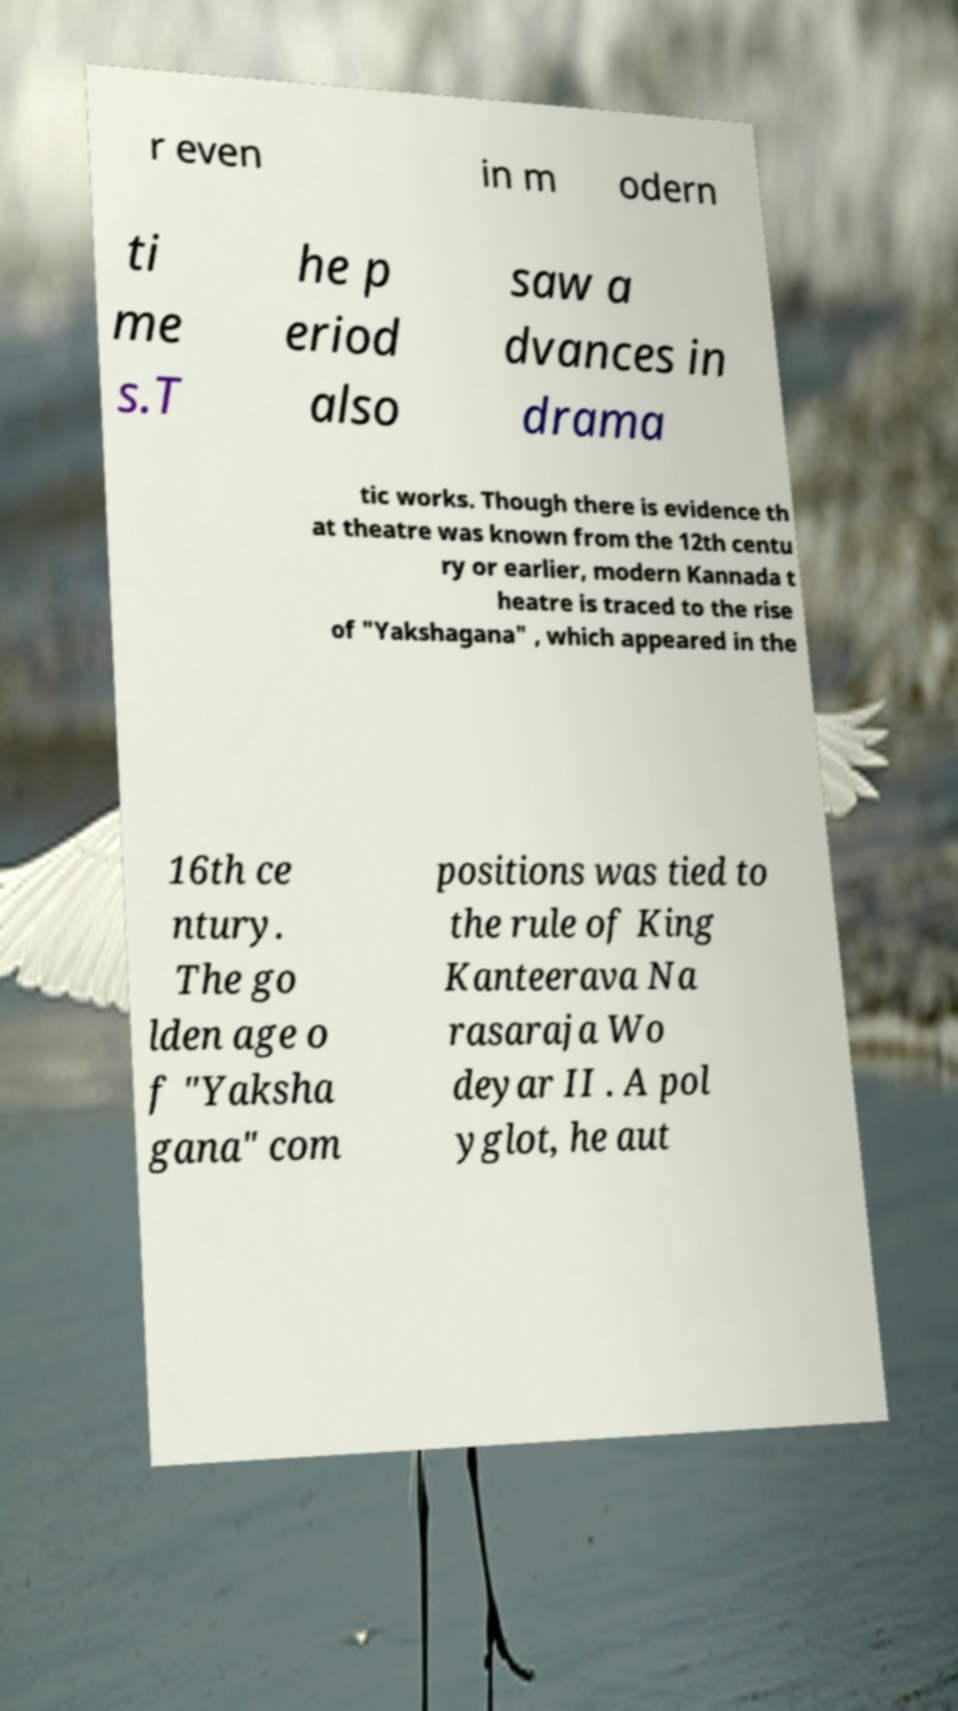Could you extract and type out the text from this image? r even in m odern ti me s.T he p eriod also saw a dvances in drama tic works. Though there is evidence th at theatre was known from the 12th centu ry or earlier, modern Kannada t heatre is traced to the rise of "Yakshagana" , which appeared in the 16th ce ntury. The go lden age o f "Yaksha gana" com positions was tied to the rule of King Kanteerava Na rasaraja Wo deyar II . A pol yglot, he aut 